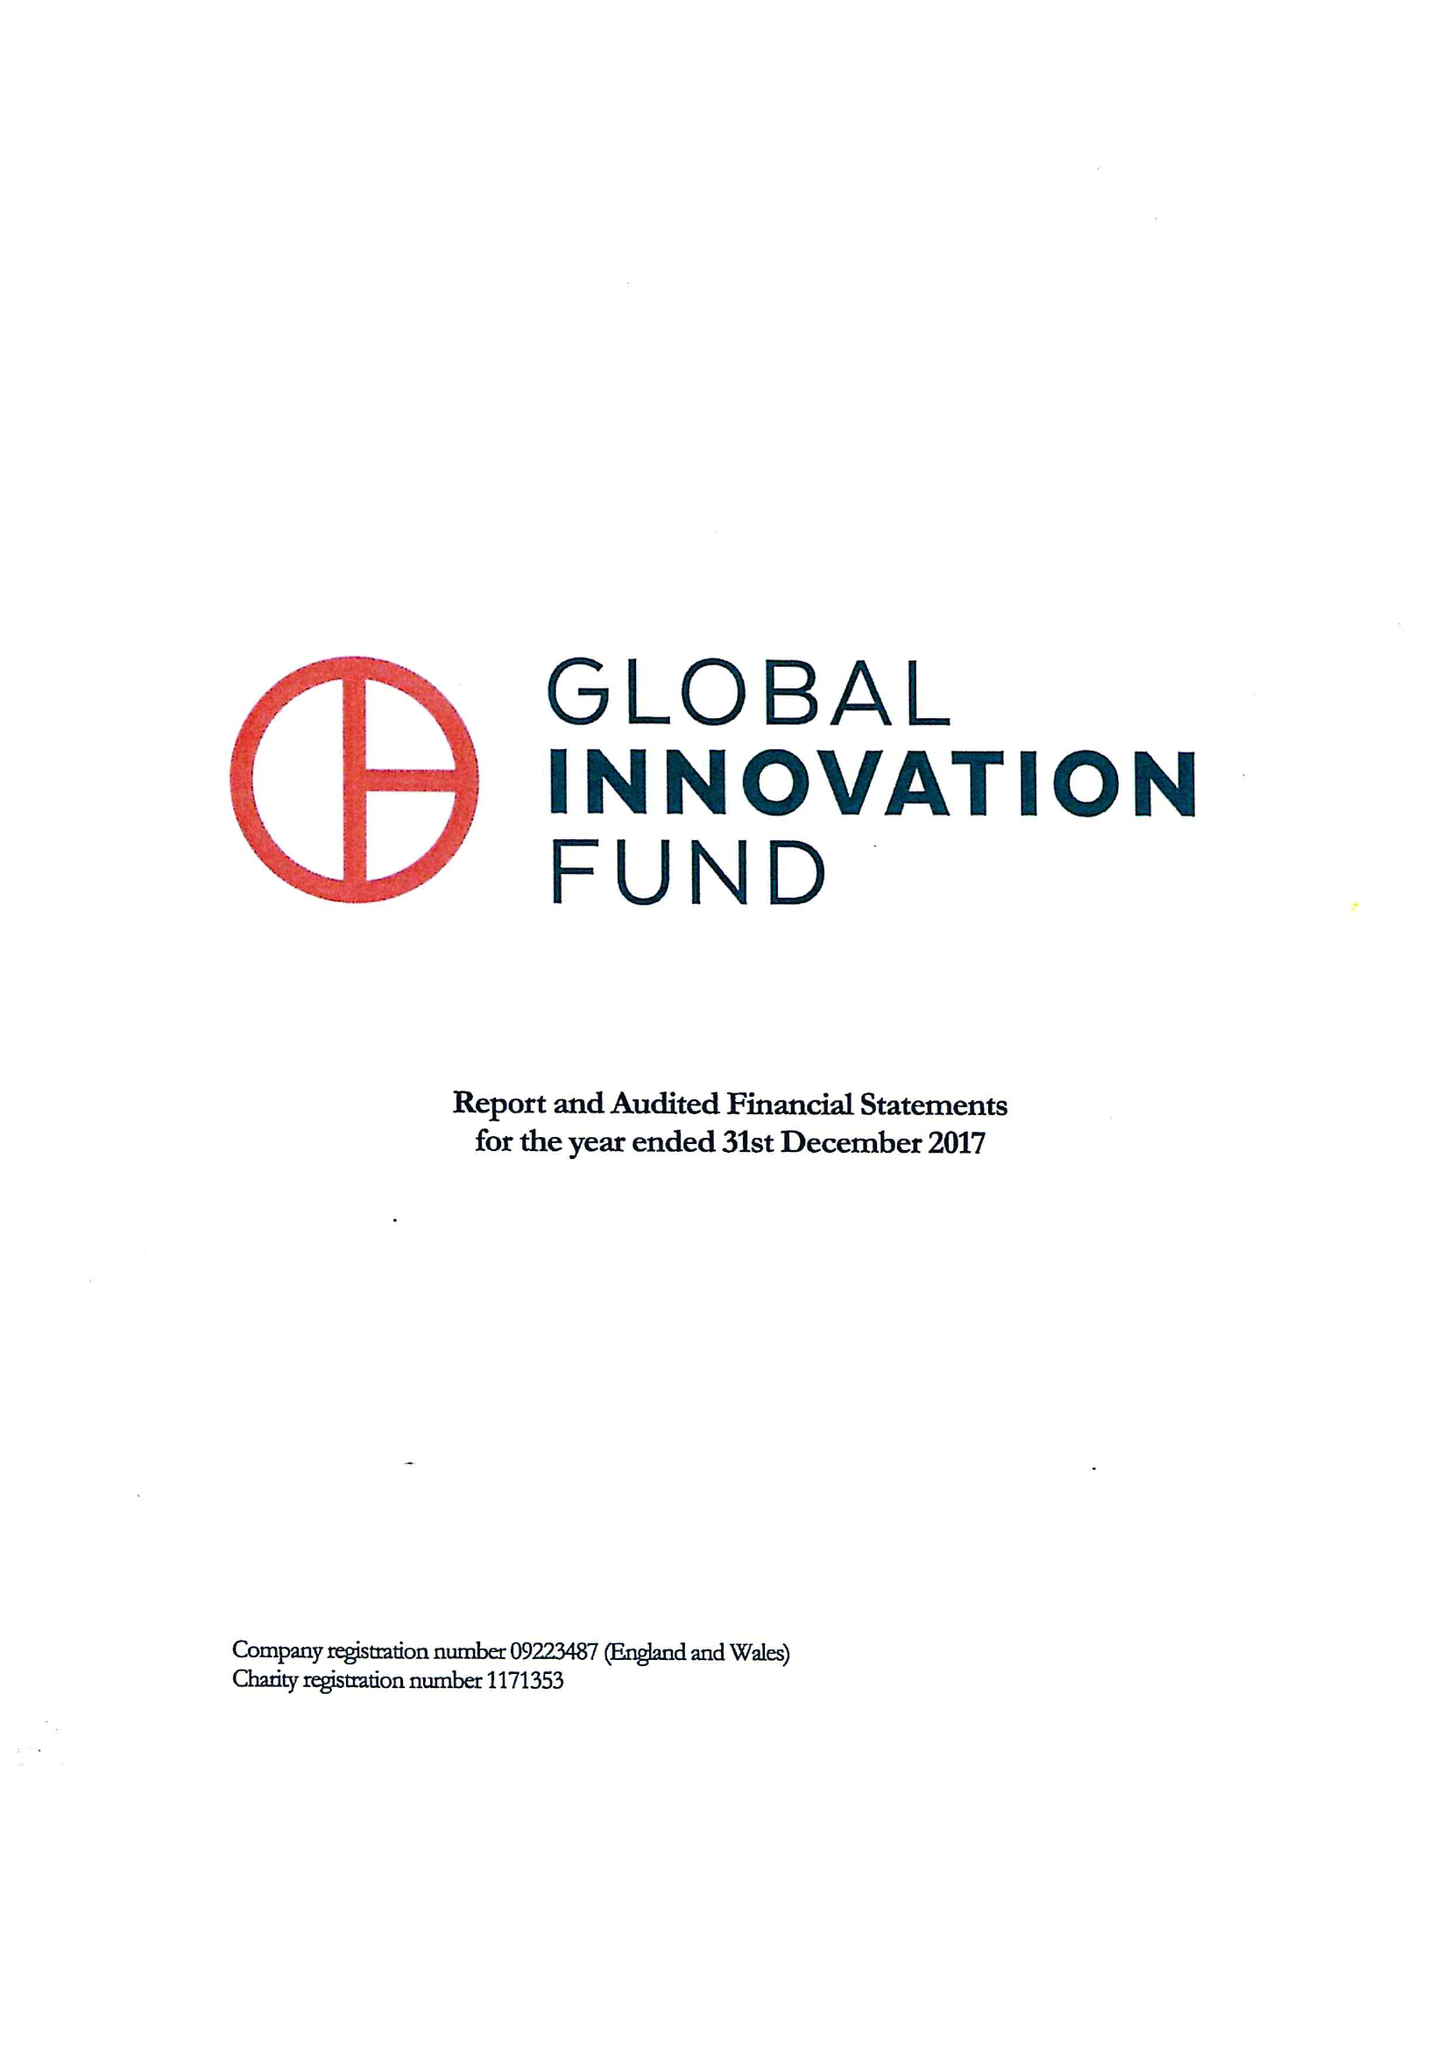What is the value for the charity_number?
Answer the question using a single word or phrase. 1171353 